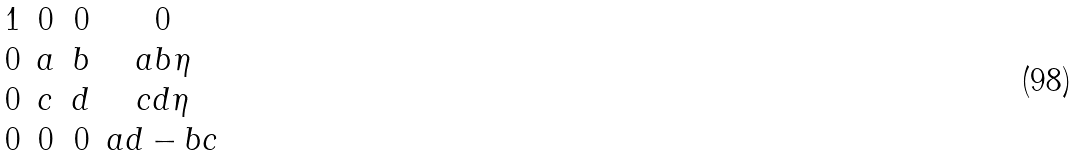<formula> <loc_0><loc_0><loc_500><loc_500>\begin{matrix} 1 & 0 & 0 & 0 \\ 0 & a & b & a b \eta \\ 0 & c & d & c d \eta \\ 0 & 0 & 0 & a d - b c \end{matrix}</formula> 